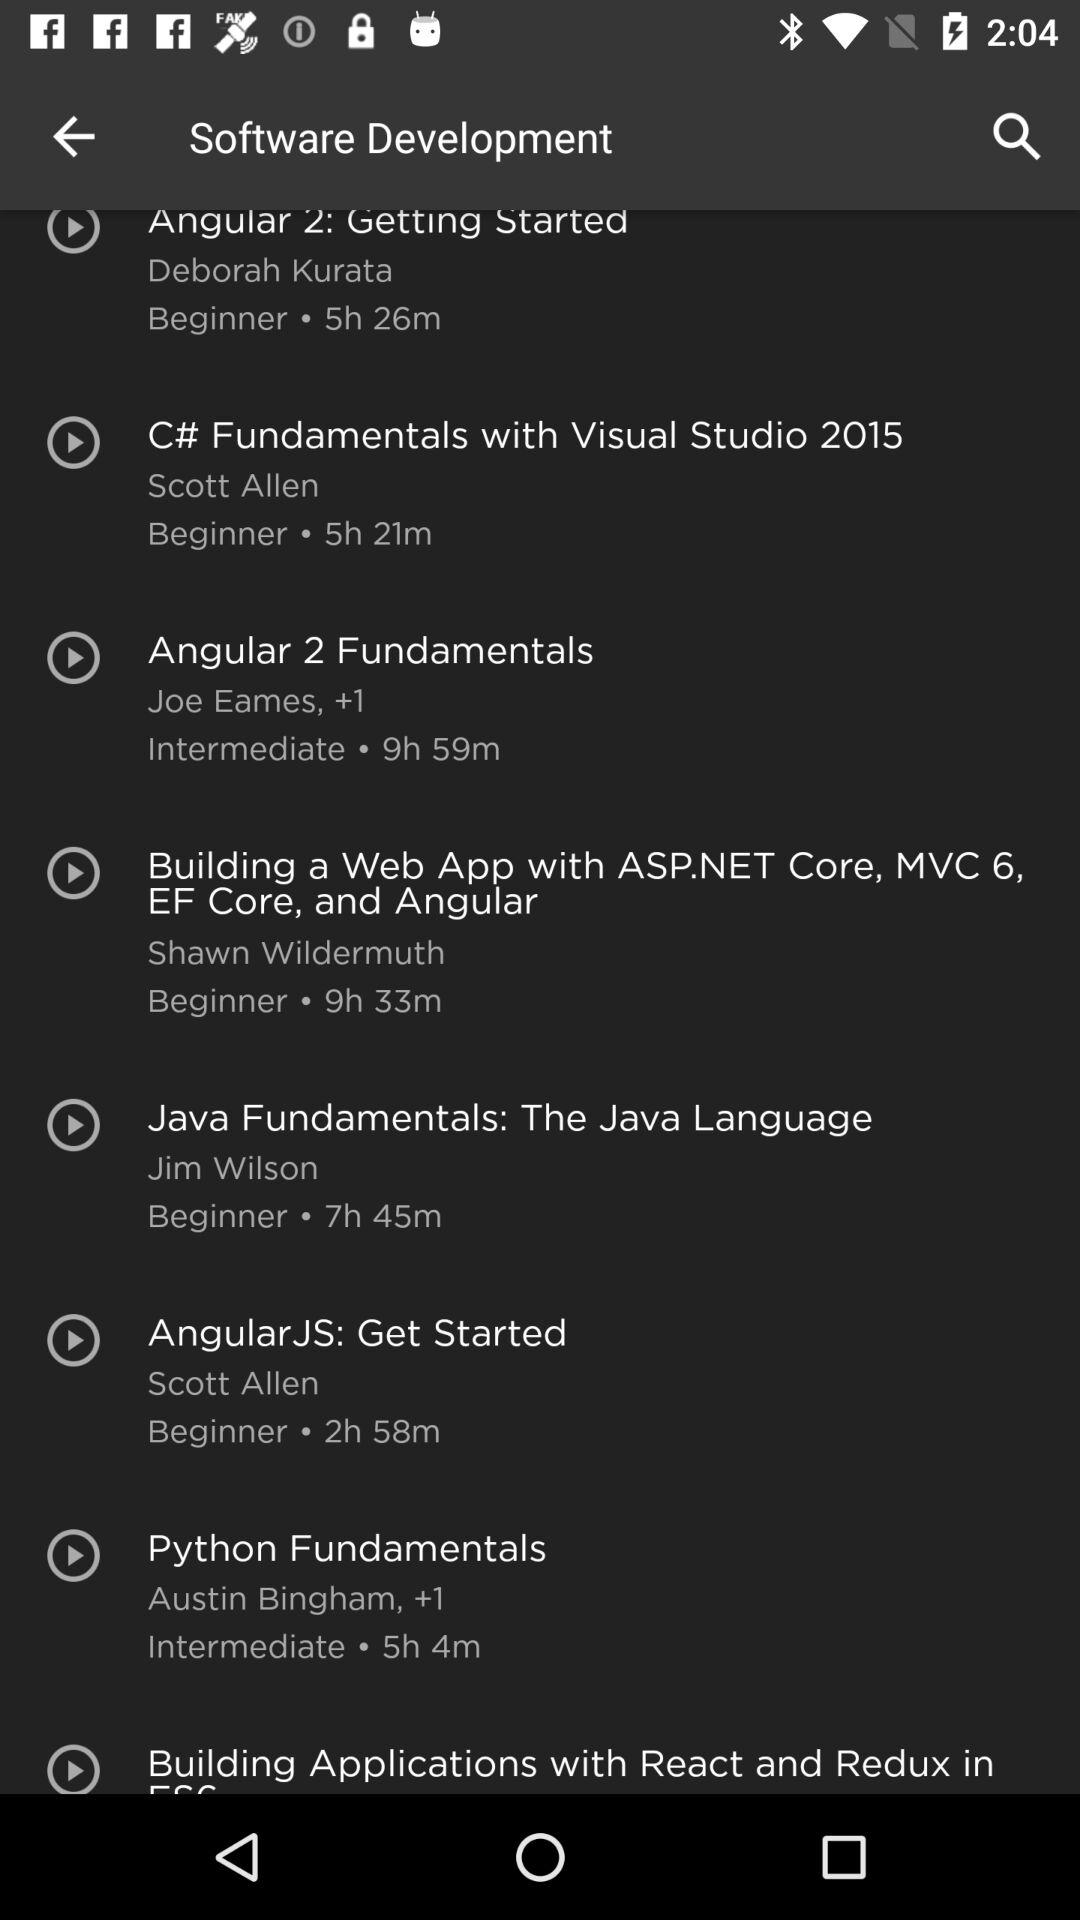What is the duration of the "Angular 2 Fundamentals" course? The duration is 9 hours and 59 minutes. 